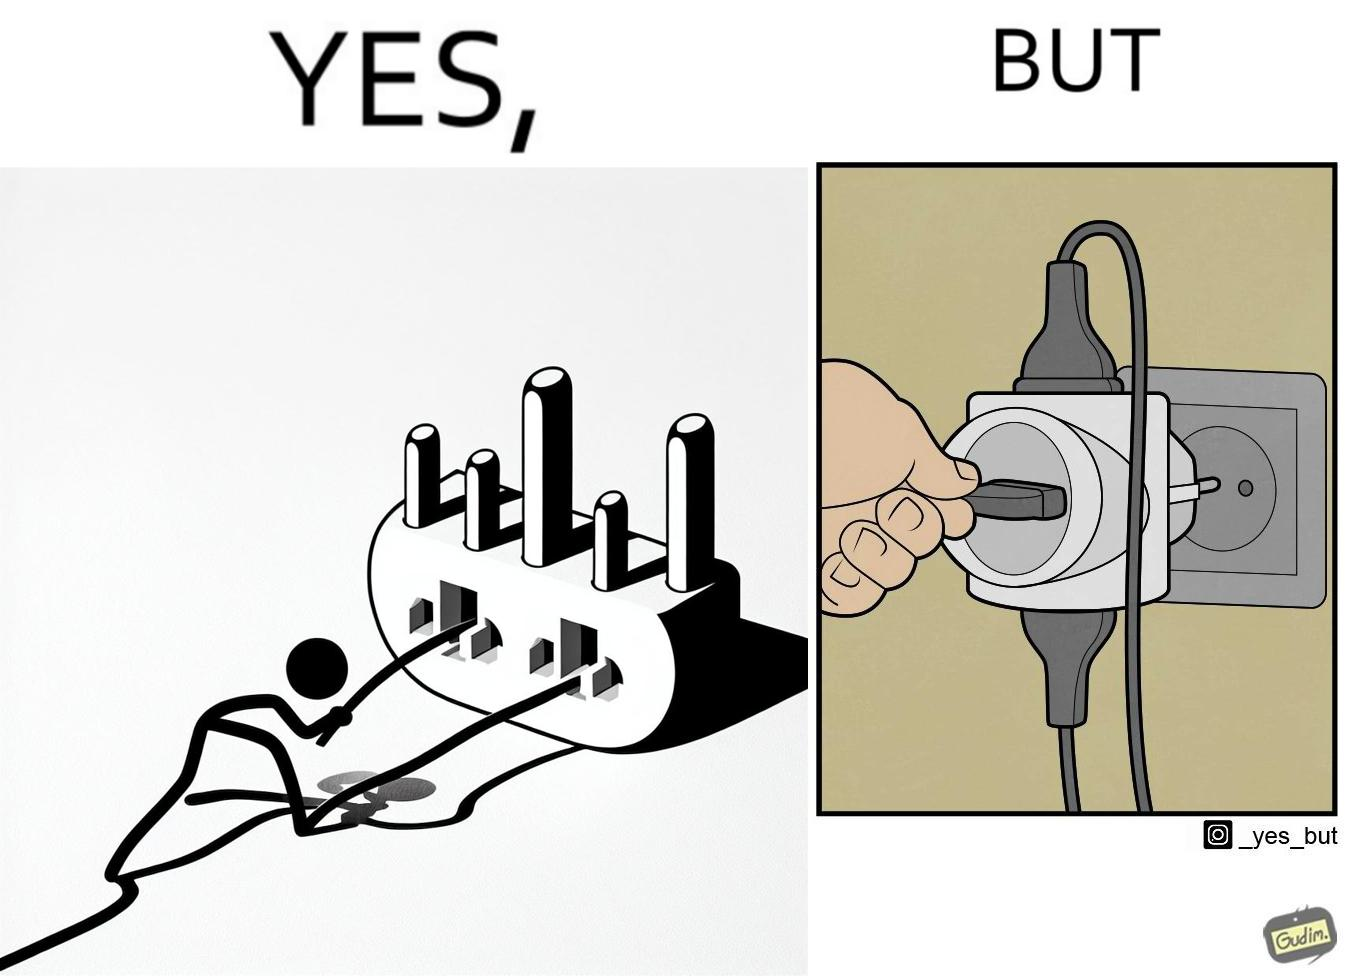Does this image contain satire or humor? Yes, this image is satirical. 